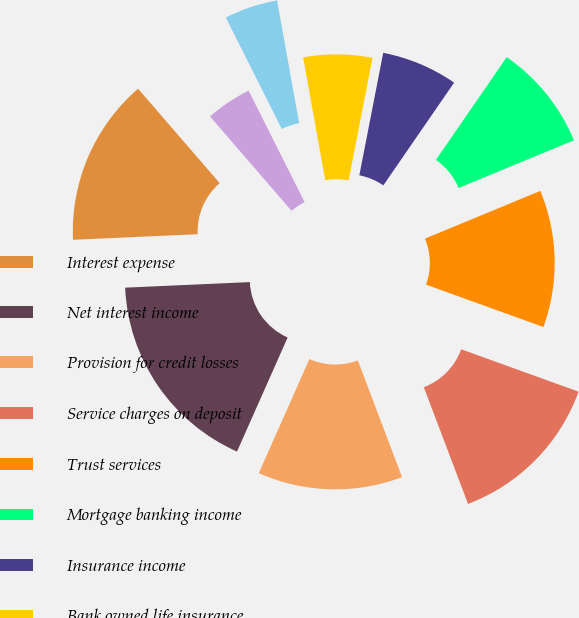Convert chart. <chart><loc_0><loc_0><loc_500><loc_500><pie_chart><fcel>Interest expense<fcel>Net interest income<fcel>Provision for credit losses<fcel>Service charges on deposit<fcel>Trust services<fcel>Mortgage banking income<fcel>Insurance income<fcel>Bank owned life insurance<fcel>Capital markets fees<fcel>Gain (loss) on sale of loans<nl><fcel>14.37%<fcel>17.64%<fcel>12.41%<fcel>13.72%<fcel>11.76%<fcel>9.15%<fcel>6.54%<fcel>5.89%<fcel>4.58%<fcel>3.93%<nl></chart> 